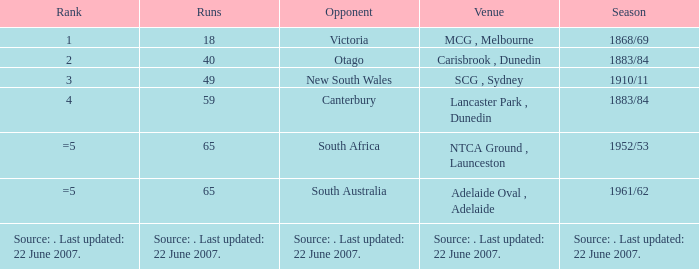How many runs has an opposition team made against south australia? 65.0. 